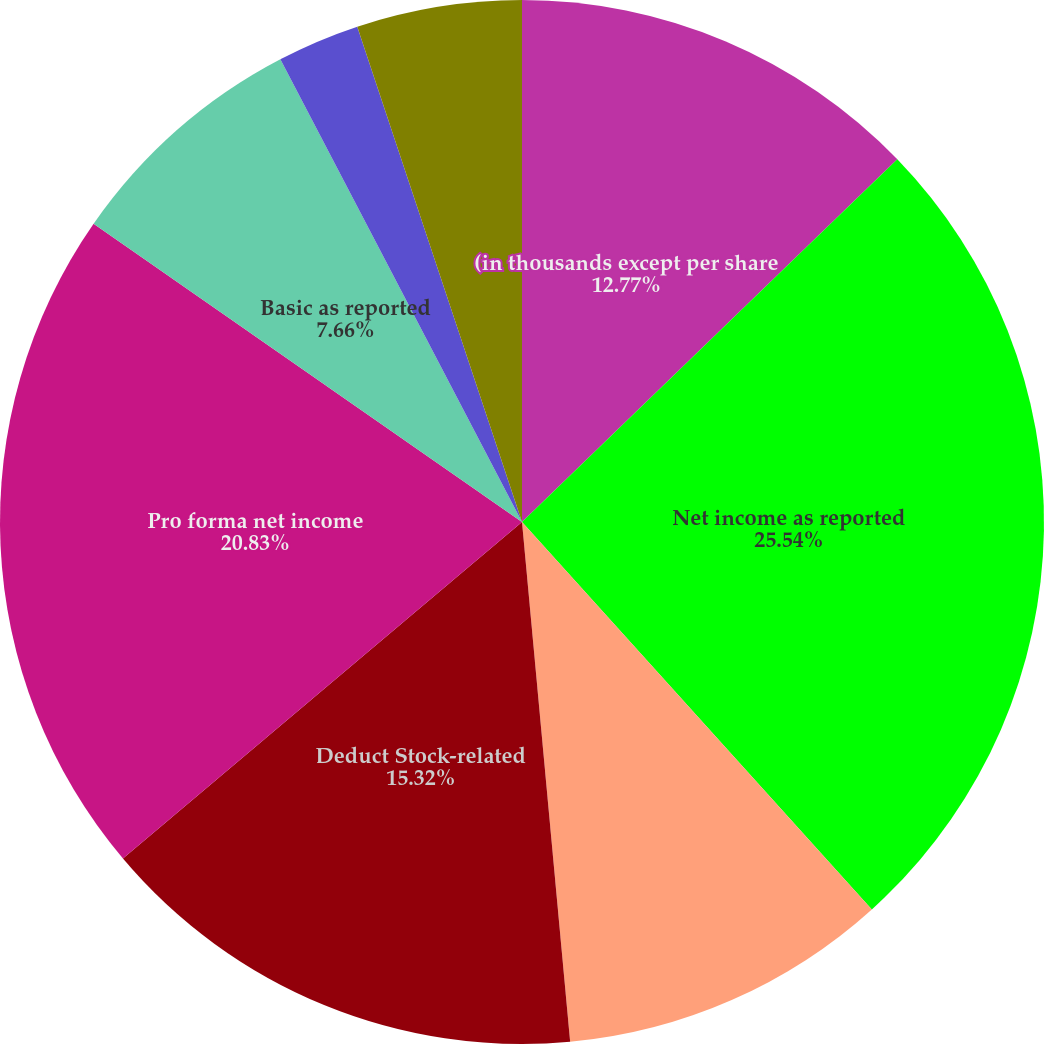Convert chart to OTSL. <chart><loc_0><loc_0><loc_500><loc_500><pie_chart><fcel>(in thousands except per share<fcel>Net income as reported<fcel>Add Stock-related compensation<fcel>Deduct Stock-related<fcel>Pro forma net income<fcel>Basic as reported<fcel>Basic pro forma<fcel>Diluted as reported<fcel>Diluted pro forma<nl><fcel>12.77%<fcel>25.54%<fcel>10.22%<fcel>15.32%<fcel>20.83%<fcel>7.66%<fcel>2.55%<fcel>5.11%<fcel>0.0%<nl></chart> 